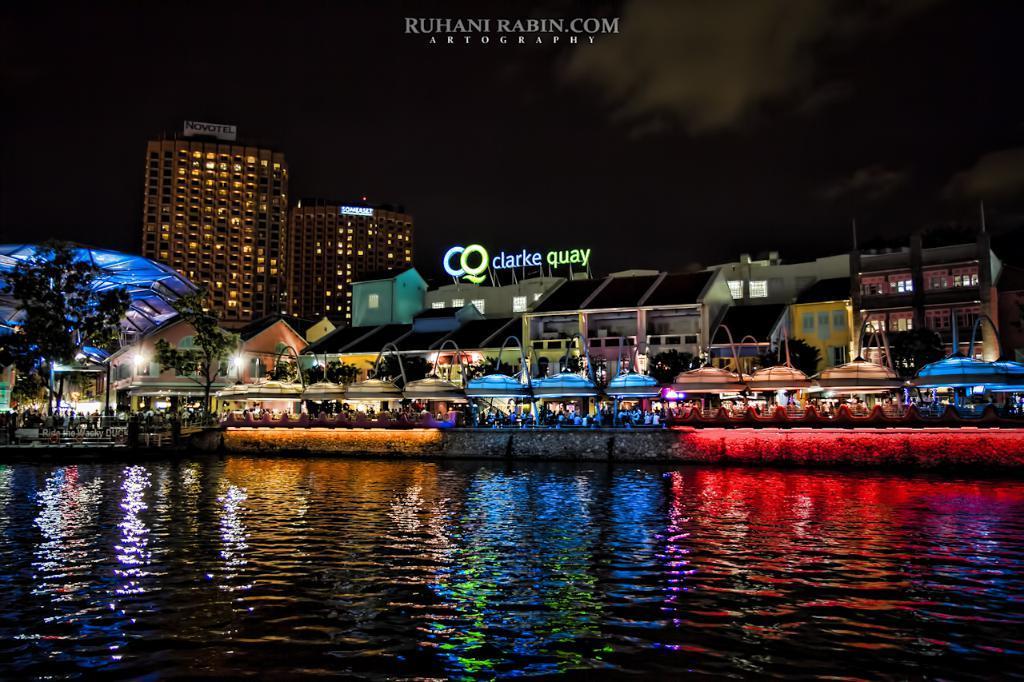In one or two sentences, can you explain what this image depicts? In this image at the bottom there are waves and water. In the middle there are buildings, trees, people, tents, lights, text. At the top there are buildings, sky, clouds and text. 